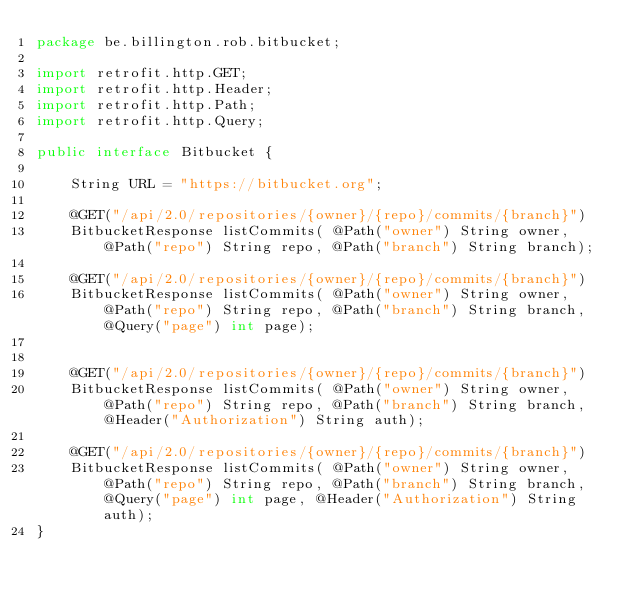Convert code to text. <code><loc_0><loc_0><loc_500><loc_500><_Java_>package be.billington.rob.bitbucket;

import retrofit.http.GET;
import retrofit.http.Header;
import retrofit.http.Path;
import retrofit.http.Query;

public interface Bitbucket {

    String URL = "https://bitbucket.org";

    @GET("/api/2.0/repositories/{owner}/{repo}/commits/{branch}")
    BitbucketResponse listCommits( @Path("owner") String owner, @Path("repo") String repo, @Path("branch") String branch);

    @GET("/api/2.0/repositories/{owner}/{repo}/commits/{branch}")
    BitbucketResponse listCommits( @Path("owner") String owner, @Path("repo") String repo, @Path("branch") String branch, @Query("page") int page);


    @GET("/api/2.0/repositories/{owner}/{repo}/commits/{branch}")
    BitbucketResponse listCommits( @Path("owner") String owner, @Path("repo") String repo, @Path("branch") String branch, @Header("Authorization") String auth);

    @GET("/api/2.0/repositories/{owner}/{repo}/commits/{branch}")
    BitbucketResponse listCommits( @Path("owner") String owner, @Path("repo") String repo, @Path("branch") String branch, @Query("page") int page, @Header("Authorization") String auth);
}
</code> 